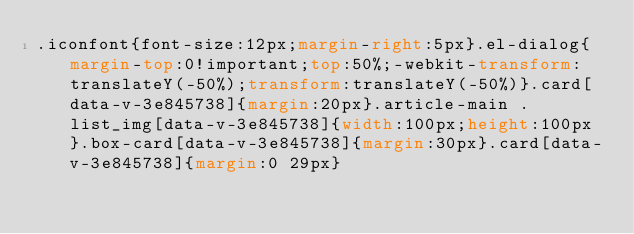<code> <loc_0><loc_0><loc_500><loc_500><_CSS_>.iconfont{font-size:12px;margin-right:5px}.el-dialog{margin-top:0!important;top:50%;-webkit-transform:translateY(-50%);transform:translateY(-50%)}.card[data-v-3e845738]{margin:20px}.article-main .list_img[data-v-3e845738]{width:100px;height:100px}.box-card[data-v-3e845738]{margin:30px}.card[data-v-3e845738]{margin:0 29px}</code> 